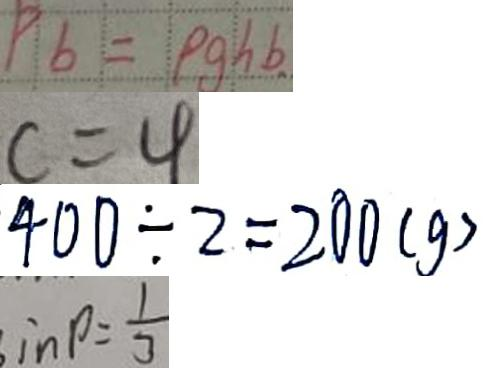<formula> <loc_0><loc_0><loc_500><loc_500>P _ { b } = p g h b 
 c = 4 
 4 0 0 \div 2 = 2 0 0 ( g ) 
 i n \rho = \frac { 1 } { 3 }</formula> 